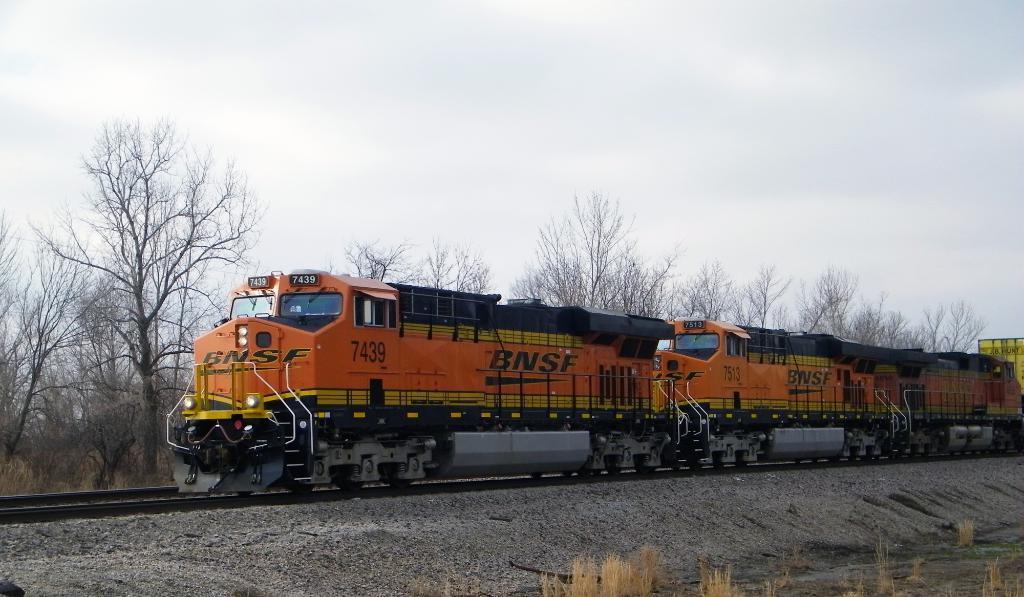Describe this image in one or two sentences. In this image there is the sky towards the top of the image, there are trees, there is a railway track, there is a train, there are plants towards the bottom of the image. 